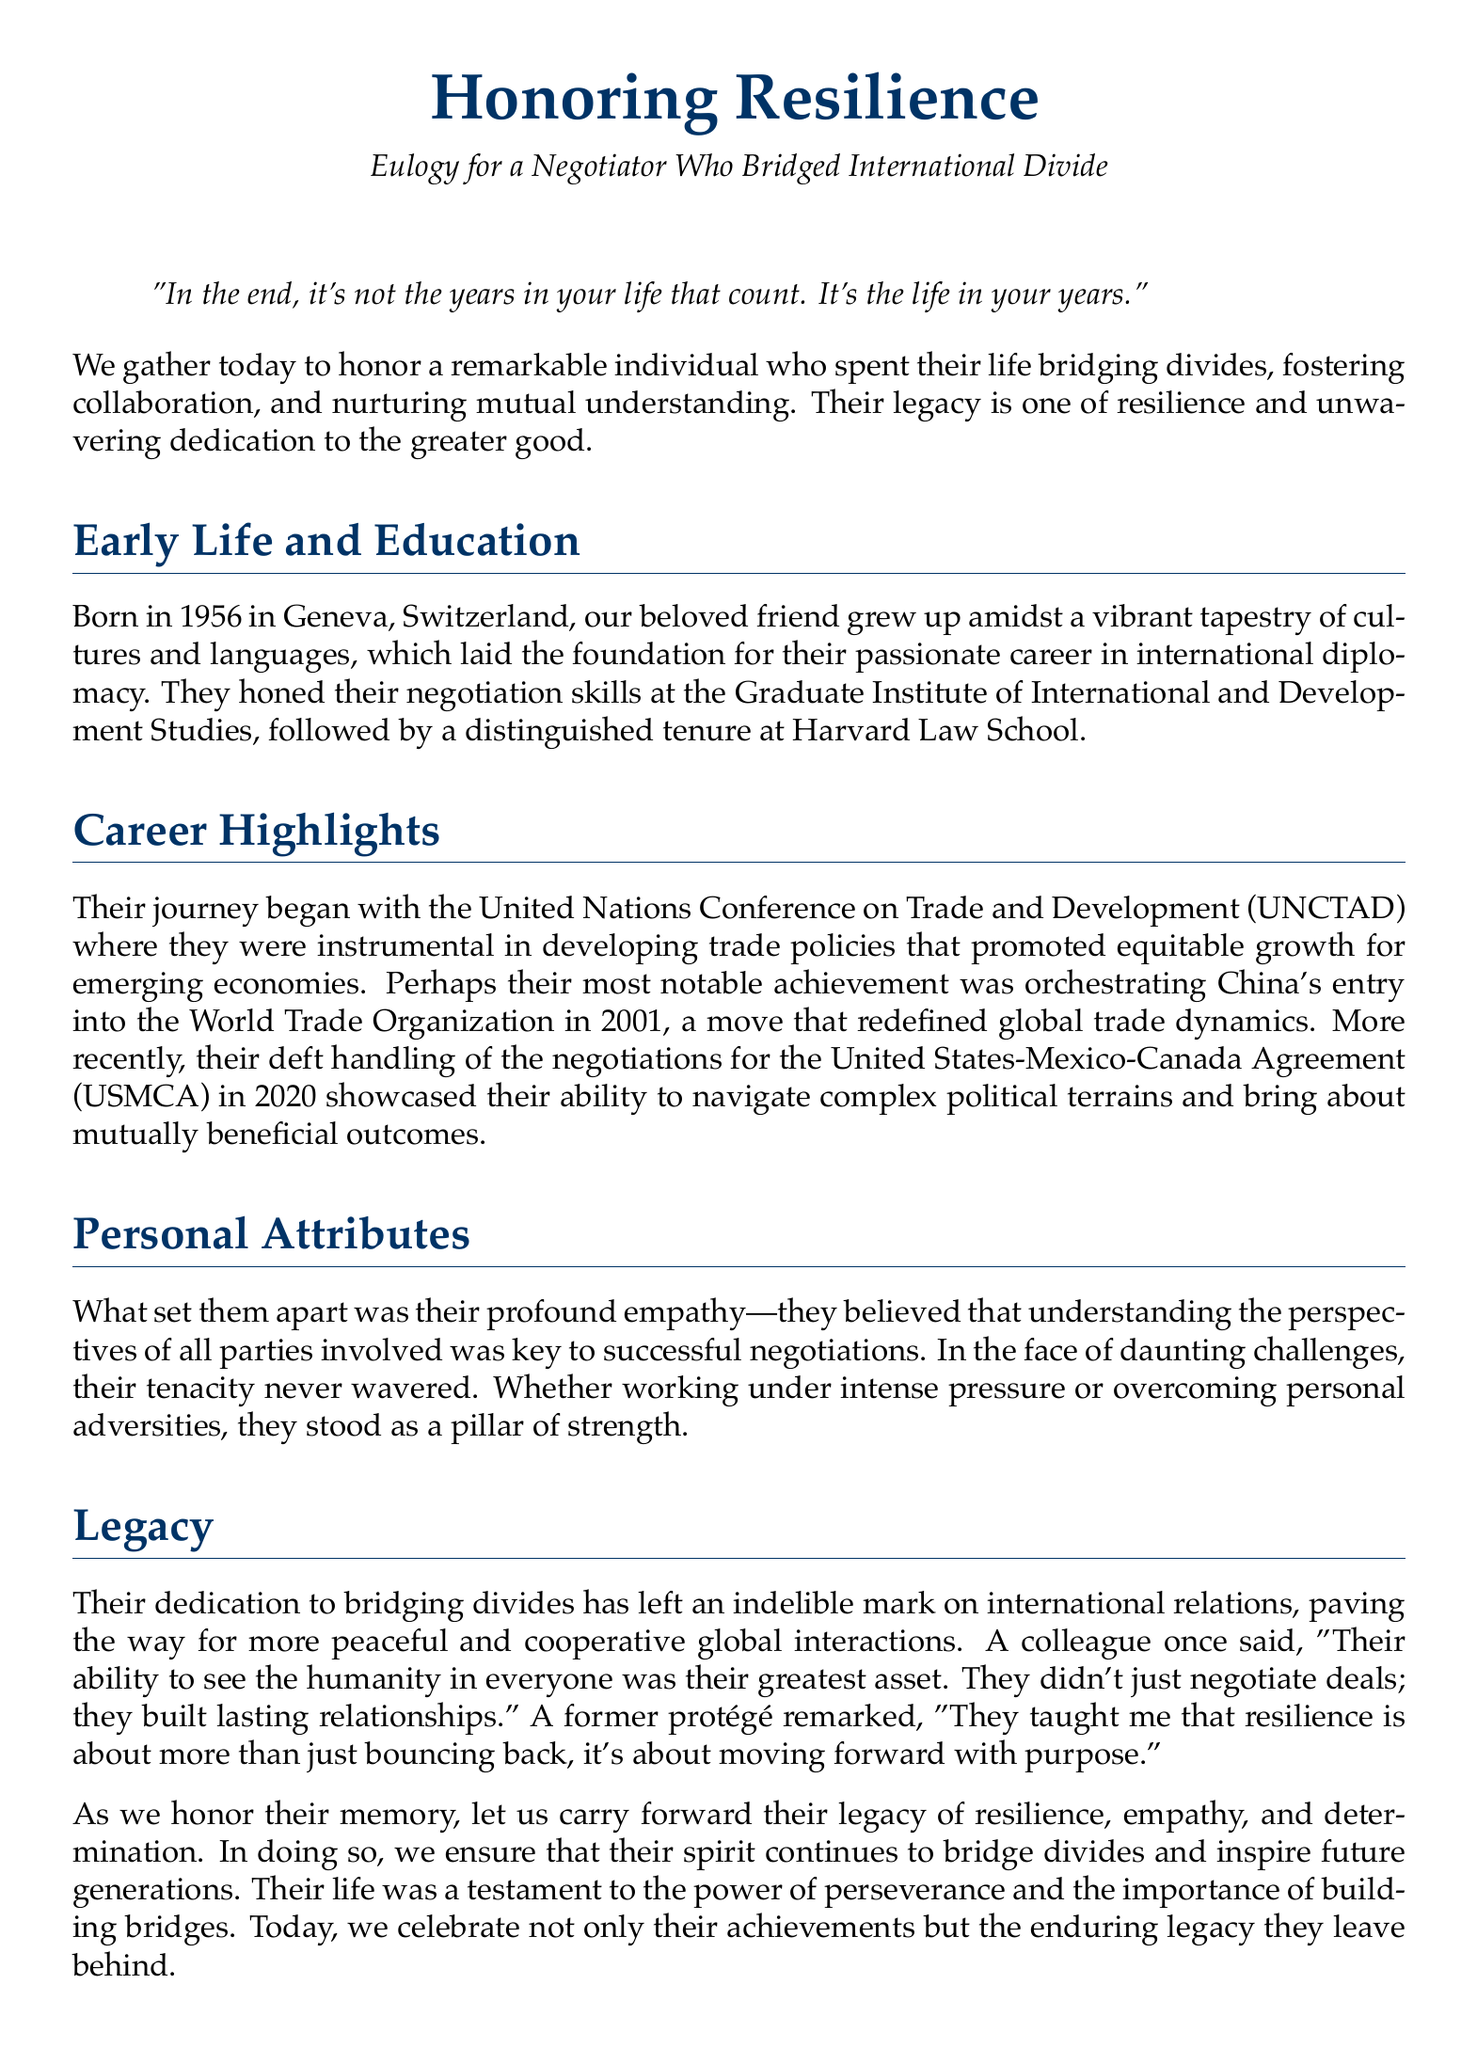what year was the negotiator born? The document states that the negotiator was born in 1956.
Answer: 1956 where did the negotiator study law? The negotiator studied law at Harvard Law School.
Answer: Harvard Law School what organization did the negotiator work for at the beginning of their career? The document mentions the United Nations Conference on Trade and Development (UNCTAD) as the starting point of their career.
Answer: UNCTAD which agreement did the negotiator work on in 2020? The negotiator was involved in the negotiations for the United States-Mexico-Canada Agreement (USMCA) in 2020.
Answer: USMCA what was a notable achievement of the negotiator in 2001? The document highlights orchestrating China's entry into the World Trade Organization as a notable achievement in 2001.
Answer: China's entry into WTO what personal attribute was highlighted in the eulogy? The eulogy emphasizes the negotiator's profound empathy as a key personal attribute.
Answer: empathy how does the eulogy describe the negotiator’s approach to negotiation? The eulogy describes the negotiator's approach as seeing the humanity in everyone and believing in understanding perspectives.
Answer: understanding perspectives what is the main theme of the eulogy? The main theme of the eulogy is honoring resilience and the legacy of bridging divides.
Answer: resilience who described the negotiator as a pillar of strength? The document implies that colleagues and protégés viewed the negotiator this way, although specific names are not provided.
Answer: colleagues and protégés 